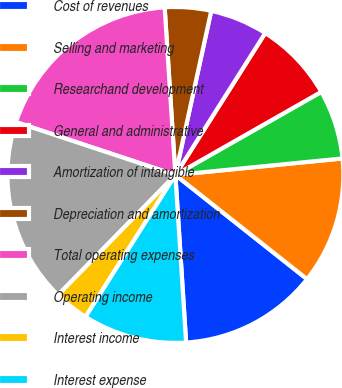Convert chart. <chart><loc_0><loc_0><loc_500><loc_500><pie_chart><fcel>Cost of revenues<fcel>Selling and marketing<fcel>Researchand development<fcel>General and administrative<fcel>Amortization of intangible<fcel>Depreciation and amortization<fcel>Total operating expenses<fcel>Operating income<fcel>Interest income<fcel>Interest expense<nl><fcel>13.33%<fcel>12.22%<fcel>6.67%<fcel>7.78%<fcel>5.56%<fcel>4.44%<fcel>18.89%<fcel>17.78%<fcel>3.33%<fcel>10.0%<nl></chart> 